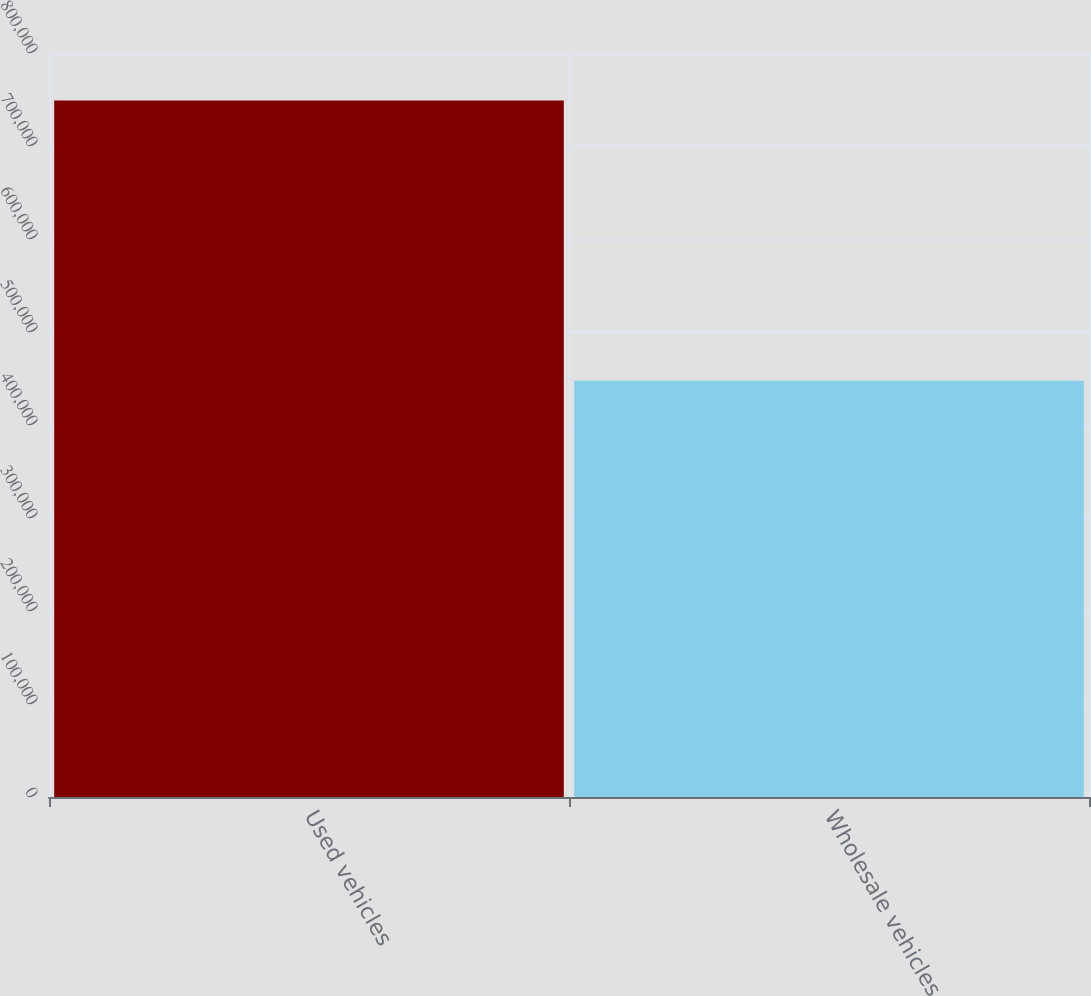Convert chart. <chart><loc_0><loc_0><loc_500><loc_500><bar_chart><fcel>Used vehicles<fcel>Wholesale vehicles<nl><fcel>748961<fcel>447491<nl></chart> 